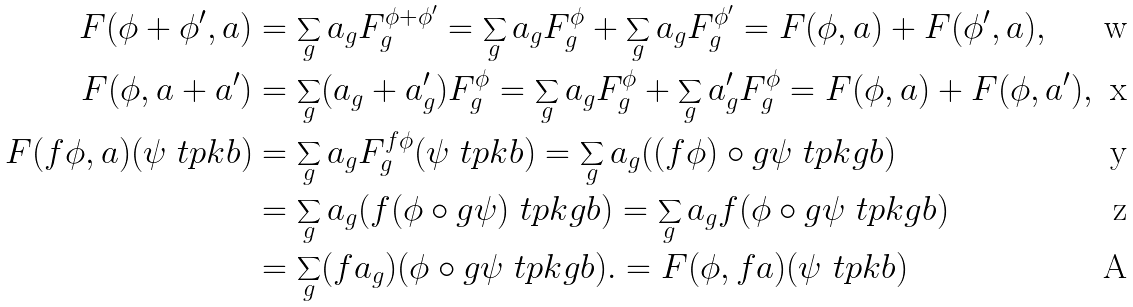<formula> <loc_0><loc_0><loc_500><loc_500>F ( \phi + \phi ^ { \prime } , a ) & = \sum _ { g } a _ { g } F _ { g } ^ { \phi + \phi ^ { \prime } } = \sum _ { g } a _ { g } F _ { g } ^ { \phi } + \sum _ { g } a _ { g } F _ { g } ^ { \phi ^ { \prime } } = F ( \phi , a ) + F ( \phi ^ { \prime } , a ) , \\ F ( \phi , a + a ^ { \prime } ) & = \sum _ { g } ( a _ { g } + a ^ { \prime } _ { g } ) F _ { g } ^ { \phi } = \sum _ { g } a _ { g } F _ { g } ^ { \phi } + \sum _ { g } a ^ { \prime } _ { g } F _ { g } ^ { \phi } = F ( \phi , a ) + F ( \phi , a ^ { \prime } ) , \\ F ( f \phi , a ) ( \psi \ t p k b ) & = \sum _ { g } a _ { g } F _ { g } ^ { f \phi } ( \psi \ t p k b ) = \sum _ { g } a _ { g } ( ( f \phi ) \circ g \psi \ t p k g b ) \\ & = \sum _ { g } a _ { g } ( f ( \phi \circ g \psi ) \ t p k g b ) = \sum _ { g } a _ { g } f ( \phi \circ g \psi \ t p k g b ) \\ & = \sum _ { g } ( f a _ { g } ) ( \phi \circ g \psi \ t p k g b ) . = F ( \phi , f a ) ( \psi \ t p k b )</formula> 